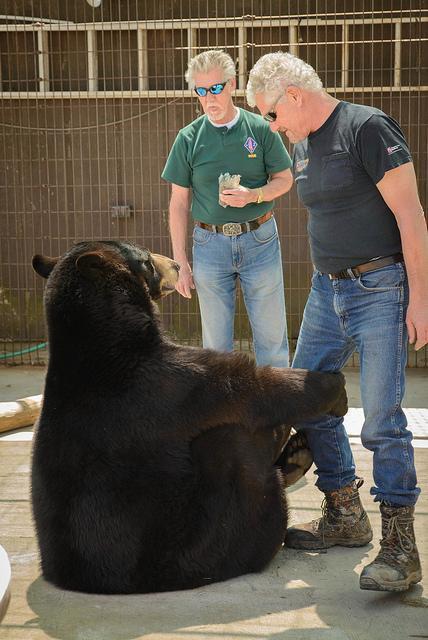How many people can be seen?
Give a very brief answer. 2. 